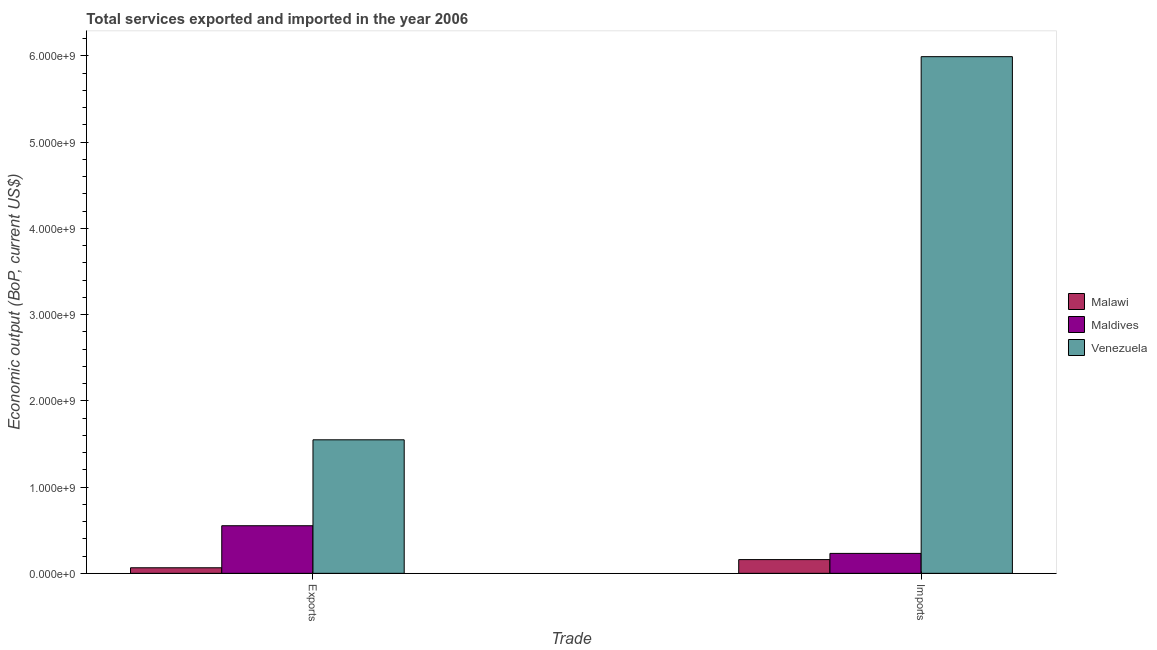How many different coloured bars are there?
Offer a very short reply. 3. How many groups of bars are there?
Offer a very short reply. 2. Are the number of bars per tick equal to the number of legend labels?
Your answer should be compact. Yes. Are the number of bars on each tick of the X-axis equal?
Your answer should be very brief. Yes. How many bars are there on the 1st tick from the left?
Ensure brevity in your answer.  3. What is the label of the 1st group of bars from the left?
Make the answer very short. Exports. What is the amount of service exports in Malawi?
Your answer should be compact. 6.45e+07. Across all countries, what is the maximum amount of service exports?
Your answer should be very brief. 1.55e+09. Across all countries, what is the minimum amount of service exports?
Offer a very short reply. 6.45e+07. In which country was the amount of service exports maximum?
Provide a succinct answer. Venezuela. In which country was the amount of service exports minimum?
Provide a succinct answer. Malawi. What is the total amount of service imports in the graph?
Your response must be concise. 6.38e+09. What is the difference between the amount of service imports in Venezuela and that in Maldives?
Offer a very short reply. 5.76e+09. What is the difference between the amount of service imports in Venezuela and the amount of service exports in Maldives?
Offer a terse response. 5.44e+09. What is the average amount of service imports per country?
Your answer should be compact. 2.13e+09. What is the difference between the amount of service exports and amount of service imports in Venezuela?
Make the answer very short. -4.44e+09. In how many countries, is the amount of service exports greater than 1800000000 US$?
Give a very brief answer. 0. What is the ratio of the amount of service exports in Maldives to that in Venezuela?
Ensure brevity in your answer.  0.36. In how many countries, is the amount of service imports greater than the average amount of service imports taken over all countries?
Provide a short and direct response. 1. What does the 2nd bar from the left in Imports represents?
Your response must be concise. Maldives. What does the 2nd bar from the right in Exports represents?
Offer a very short reply. Maldives. What is the difference between two consecutive major ticks on the Y-axis?
Your response must be concise. 1.00e+09. Does the graph contain grids?
Give a very brief answer. No. How are the legend labels stacked?
Make the answer very short. Vertical. What is the title of the graph?
Your answer should be compact. Total services exported and imported in the year 2006. What is the label or title of the X-axis?
Your answer should be very brief. Trade. What is the label or title of the Y-axis?
Your answer should be compact. Economic output (BoP, current US$). What is the Economic output (BoP, current US$) in Malawi in Exports?
Your answer should be very brief. 6.45e+07. What is the Economic output (BoP, current US$) of Maldives in Exports?
Make the answer very short. 5.52e+08. What is the Economic output (BoP, current US$) of Venezuela in Exports?
Ensure brevity in your answer.  1.55e+09. What is the Economic output (BoP, current US$) of Malawi in Imports?
Give a very brief answer. 1.59e+08. What is the Economic output (BoP, current US$) in Maldives in Imports?
Your response must be concise. 2.31e+08. What is the Economic output (BoP, current US$) in Venezuela in Imports?
Provide a short and direct response. 5.99e+09. Across all Trade, what is the maximum Economic output (BoP, current US$) of Malawi?
Offer a very short reply. 1.59e+08. Across all Trade, what is the maximum Economic output (BoP, current US$) in Maldives?
Provide a short and direct response. 5.52e+08. Across all Trade, what is the maximum Economic output (BoP, current US$) in Venezuela?
Give a very brief answer. 5.99e+09. Across all Trade, what is the minimum Economic output (BoP, current US$) of Malawi?
Offer a very short reply. 6.45e+07. Across all Trade, what is the minimum Economic output (BoP, current US$) of Maldives?
Your answer should be compact. 2.31e+08. Across all Trade, what is the minimum Economic output (BoP, current US$) in Venezuela?
Offer a very short reply. 1.55e+09. What is the total Economic output (BoP, current US$) of Malawi in the graph?
Ensure brevity in your answer.  2.24e+08. What is the total Economic output (BoP, current US$) of Maldives in the graph?
Ensure brevity in your answer.  7.83e+08. What is the total Economic output (BoP, current US$) of Venezuela in the graph?
Give a very brief answer. 7.54e+09. What is the difference between the Economic output (BoP, current US$) of Malawi in Exports and that in Imports?
Offer a terse response. -9.47e+07. What is the difference between the Economic output (BoP, current US$) in Maldives in Exports and that in Imports?
Give a very brief answer. 3.21e+08. What is the difference between the Economic output (BoP, current US$) in Venezuela in Exports and that in Imports?
Your response must be concise. -4.44e+09. What is the difference between the Economic output (BoP, current US$) of Malawi in Exports and the Economic output (BoP, current US$) of Maldives in Imports?
Offer a terse response. -1.67e+08. What is the difference between the Economic output (BoP, current US$) of Malawi in Exports and the Economic output (BoP, current US$) of Venezuela in Imports?
Give a very brief answer. -5.93e+09. What is the difference between the Economic output (BoP, current US$) in Maldives in Exports and the Economic output (BoP, current US$) in Venezuela in Imports?
Your response must be concise. -5.44e+09. What is the average Economic output (BoP, current US$) of Malawi per Trade?
Give a very brief answer. 1.12e+08. What is the average Economic output (BoP, current US$) of Maldives per Trade?
Offer a terse response. 3.92e+08. What is the average Economic output (BoP, current US$) in Venezuela per Trade?
Offer a terse response. 3.77e+09. What is the difference between the Economic output (BoP, current US$) in Malawi and Economic output (BoP, current US$) in Maldives in Exports?
Your answer should be very brief. -4.87e+08. What is the difference between the Economic output (BoP, current US$) of Malawi and Economic output (BoP, current US$) of Venezuela in Exports?
Ensure brevity in your answer.  -1.48e+09. What is the difference between the Economic output (BoP, current US$) in Maldives and Economic output (BoP, current US$) in Venezuela in Exports?
Provide a short and direct response. -9.96e+08. What is the difference between the Economic output (BoP, current US$) of Malawi and Economic output (BoP, current US$) of Maldives in Imports?
Ensure brevity in your answer.  -7.19e+07. What is the difference between the Economic output (BoP, current US$) of Malawi and Economic output (BoP, current US$) of Venezuela in Imports?
Your answer should be compact. -5.83e+09. What is the difference between the Economic output (BoP, current US$) of Maldives and Economic output (BoP, current US$) of Venezuela in Imports?
Give a very brief answer. -5.76e+09. What is the ratio of the Economic output (BoP, current US$) in Malawi in Exports to that in Imports?
Your answer should be compact. 0.41. What is the ratio of the Economic output (BoP, current US$) of Maldives in Exports to that in Imports?
Keep it short and to the point. 2.39. What is the ratio of the Economic output (BoP, current US$) in Venezuela in Exports to that in Imports?
Your answer should be very brief. 0.26. What is the difference between the highest and the second highest Economic output (BoP, current US$) of Malawi?
Make the answer very short. 9.47e+07. What is the difference between the highest and the second highest Economic output (BoP, current US$) in Maldives?
Provide a short and direct response. 3.21e+08. What is the difference between the highest and the second highest Economic output (BoP, current US$) of Venezuela?
Give a very brief answer. 4.44e+09. What is the difference between the highest and the lowest Economic output (BoP, current US$) of Malawi?
Provide a short and direct response. 9.47e+07. What is the difference between the highest and the lowest Economic output (BoP, current US$) in Maldives?
Your response must be concise. 3.21e+08. What is the difference between the highest and the lowest Economic output (BoP, current US$) of Venezuela?
Offer a terse response. 4.44e+09. 